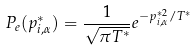Convert formula to latex. <formula><loc_0><loc_0><loc_500><loc_500>P _ { e } ( p _ { i , \alpha } ^ { * } ) = \frac { 1 } { \sqrt { \pi T ^ { * } } } e ^ { - p _ { i , \alpha } ^ { * 2 } / T ^ { * } }</formula> 